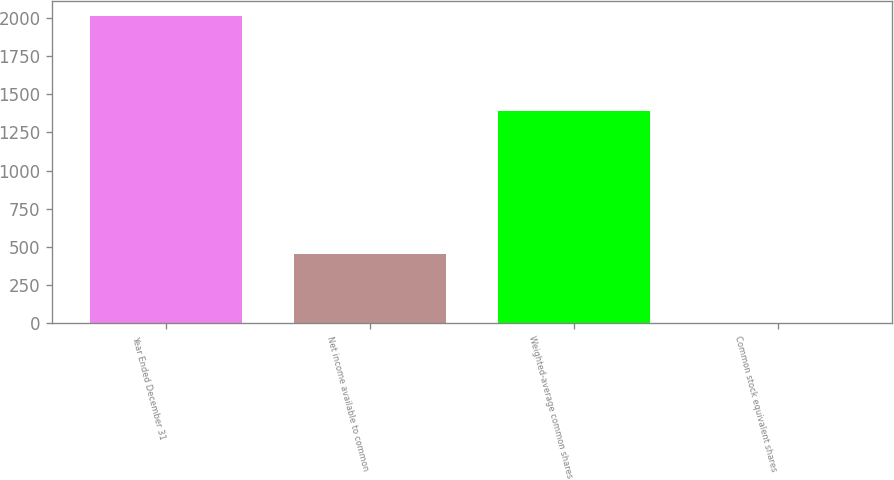<chart> <loc_0><loc_0><loc_500><loc_500><bar_chart><fcel>Year Ended December 31<fcel>Net income available to common<fcel>Weighted-average common shares<fcel>Common stock equivalent shares<nl><fcel>2010<fcel>454<fcel>1391.7<fcel>3<nl></chart> 